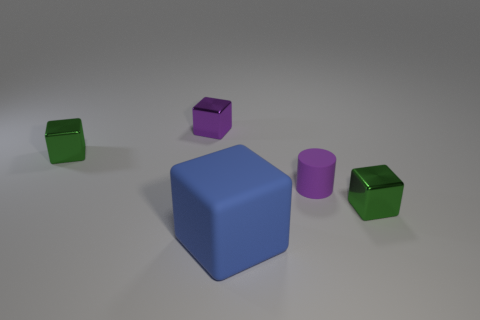Subtract all metal blocks. How many blocks are left? 1 Subtract all blocks. How many objects are left? 1 Subtract 1 cylinders. How many cylinders are left? 0 Add 4 big purple rubber balls. How many objects exist? 9 Subtract all purple cubes. How many cubes are left? 3 Subtract 0 cyan blocks. How many objects are left? 5 Subtract all red blocks. Subtract all cyan spheres. How many blocks are left? 4 Subtract all yellow balls. How many gray cubes are left? 0 Subtract all metal blocks. Subtract all tiny green shiny things. How many objects are left? 0 Add 5 green metal cubes. How many green metal cubes are left? 7 